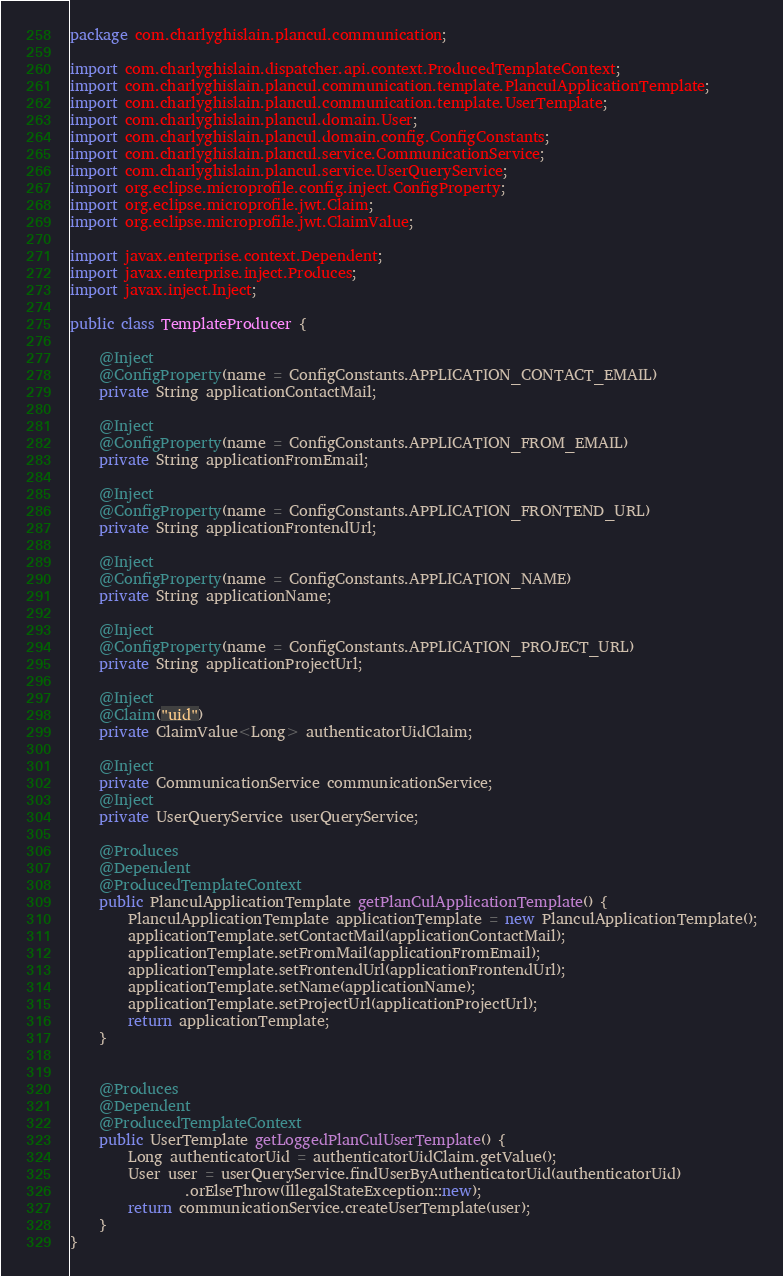Convert code to text. <code><loc_0><loc_0><loc_500><loc_500><_Java_>package com.charlyghislain.plancul.communication;

import com.charlyghislain.dispatcher.api.context.ProducedTemplateContext;
import com.charlyghislain.plancul.communication.template.PlanculApplicationTemplate;
import com.charlyghislain.plancul.communication.template.UserTemplate;
import com.charlyghislain.plancul.domain.User;
import com.charlyghislain.plancul.domain.config.ConfigConstants;
import com.charlyghislain.plancul.service.CommunicationService;
import com.charlyghislain.plancul.service.UserQueryService;
import org.eclipse.microprofile.config.inject.ConfigProperty;
import org.eclipse.microprofile.jwt.Claim;
import org.eclipse.microprofile.jwt.ClaimValue;

import javax.enterprise.context.Dependent;
import javax.enterprise.inject.Produces;
import javax.inject.Inject;

public class TemplateProducer {

    @Inject
    @ConfigProperty(name = ConfigConstants.APPLICATION_CONTACT_EMAIL)
    private String applicationContactMail;

    @Inject
    @ConfigProperty(name = ConfigConstants.APPLICATION_FROM_EMAIL)
    private String applicationFromEmail;

    @Inject
    @ConfigProperty(name = ConfigConstants.APPLICATION_FRONTEND_URL)
    private String applicationFrontendUrl;

    @Inject
    @ConfigProperty(name = ConfigConstants.APPLICATION_NAME)
    private String applicationName;

    @Inject
    @ConfigProperty(name = ConfigConstants.APPLICATION_PROJECT_URL)
    private String applicationProjectUrl;

    @Inject
    @Claim("uid")
    private ClaimValue<Long> authenticatorUidClaim;

    @Inject
    private CommunicationService communicationService;
    @Inject
    private UserQueryService userQueryService;

    @Produces
    @Dependent
    @ProducedTemplateContext
    public PlanculApplicationTemplate getPlanCulApplicationTemplate() {
        PlanculApplicationTemplate applicationTemplate = new PlanculApplicationTemplate();
        applicationTemplate.setContactMail(applicationContactMail);
        applicationTemplate.setFromMail(applicationFromEmail);
        applicationTemplate.setFrontendUrl(applicationFrontendUrl);
        applicationTemplate.setName(applicationName);
        applicationTemplate.setProjectUrl(applicationProjectUrl);
        return applicationTemplate;
    }


    @Produces
    @Dependent
    @ProducedTemplateContext
    public UserTemplate getLoggedPlanCulUserTemplate() {
        Long authenticatorUid = authenticatorUidClaim.getValue();
        User user = userQueryService.findUserByAuthenticatorUid(authenticatorUid)
                .orElseThrow(IllegalStateException::new);
        return communicationService.createUserTemplate(user);
    }
}
</code> 